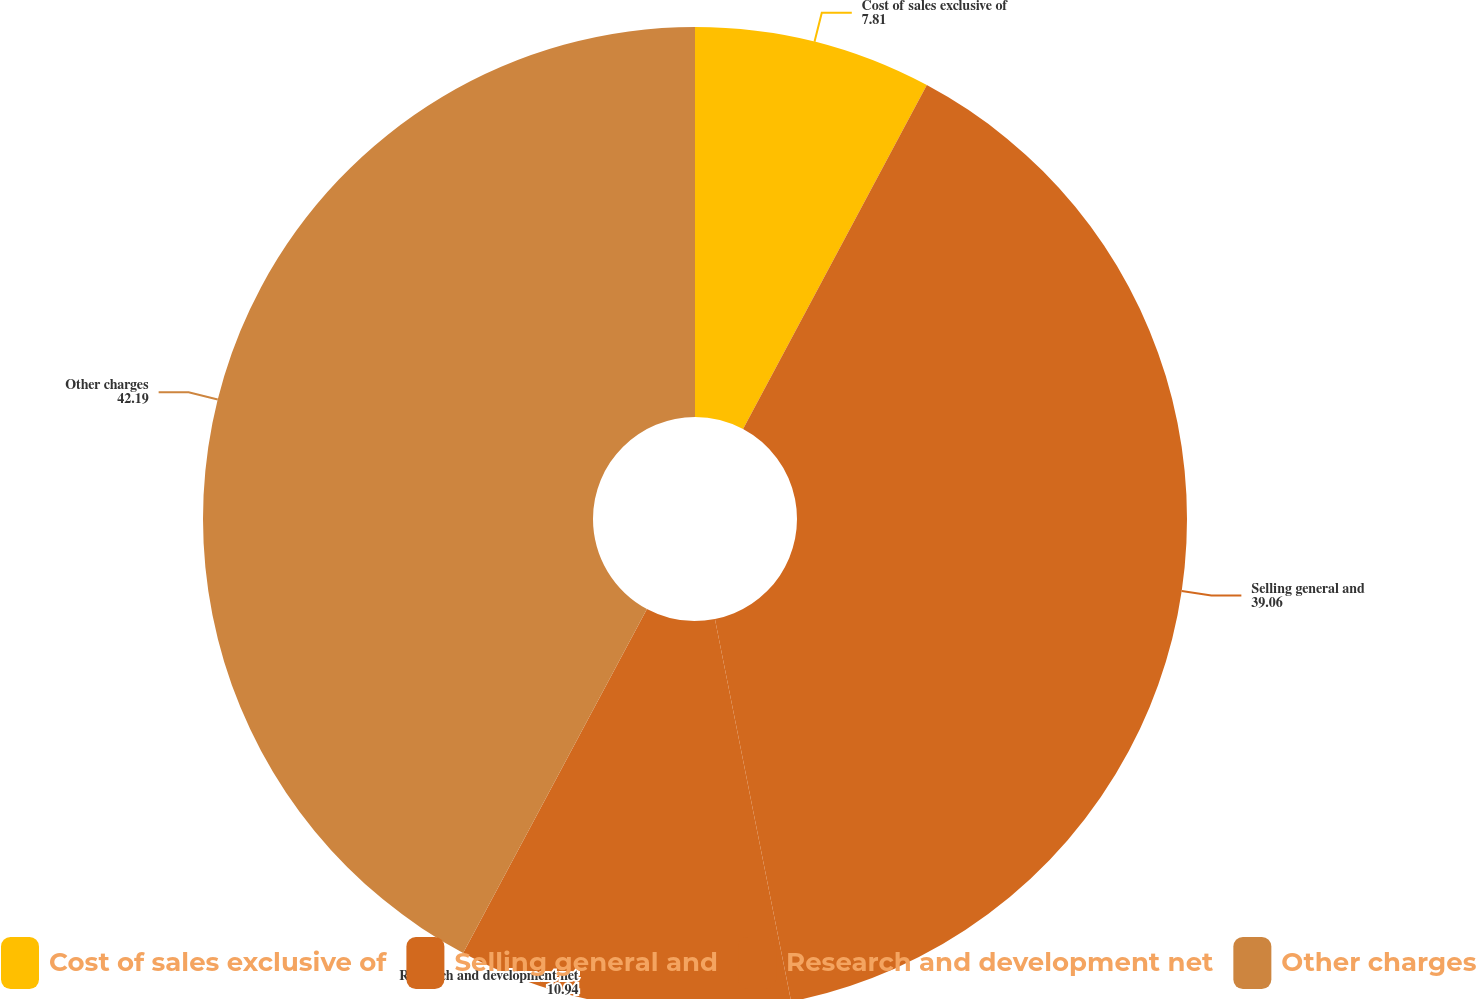Convert chart to OTSL. <chart><loc_0><loc_0><loc_500><loc_500><pie_chart><fcel>Cost of sales exclusive of<fcel>Selling general and<fcel>Research and development net<fcel>Other charges<nl><fcel>7.81%<fcel>39.06%<fcel>10.94%<fcel>42.19%<nl></chart> 